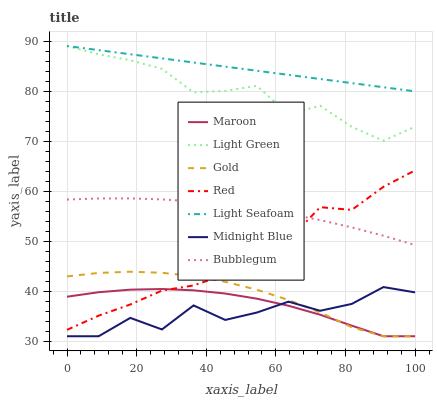Does Midnight Blue have the minimum area under the curve?
Answer yes or no. Yes. Does Light Seafoam have the maximum area under the curve?
Answer yes or no. Yes. Does Gold have the minimum area under the curve?
Answer yes or no. No. Does Gold have the maximum area under the curve?
Answer yes or no. No. Is Light Seafoam the smoothest?
Answer yes or no. Yes. Is Midnight Blue the roughest?
Answer yes or no. Yes. Is Gold the smoothest?
Answer yes or no. No. Is Gold the roughest?
Answer yes or no. No. Does Midnight Blue have the lowest value?
Answer yes or no. Yes. Does Bubblegum have the lowest value?
Answer yes or no. No. Does Light Seafoam have the highest value?
Answer yes or no. Yes. Does Gold have the highest value?
Answer yes or no. No. Is Red less than Light Seafoam?
Answer yes or no. Yes. Is Bubblegum greater than Maroon?
Answer yes or no. Yes. Does Red intersect Maroon?
Answer yes or no. Yes. Is Red less than Maroon?
Answer yes or no. No. Is Red greater than Maroon?
Answer yes or no. No. Does Red intersect Light Seafoam?
Answer yes or no. No. 